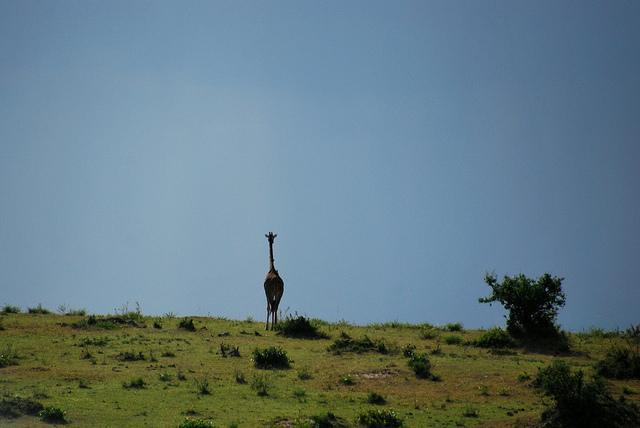How many animals are facing the camera?
Give a very brief answer. 1. How many animals are in the picture?
Give a very brief answer. 1. 